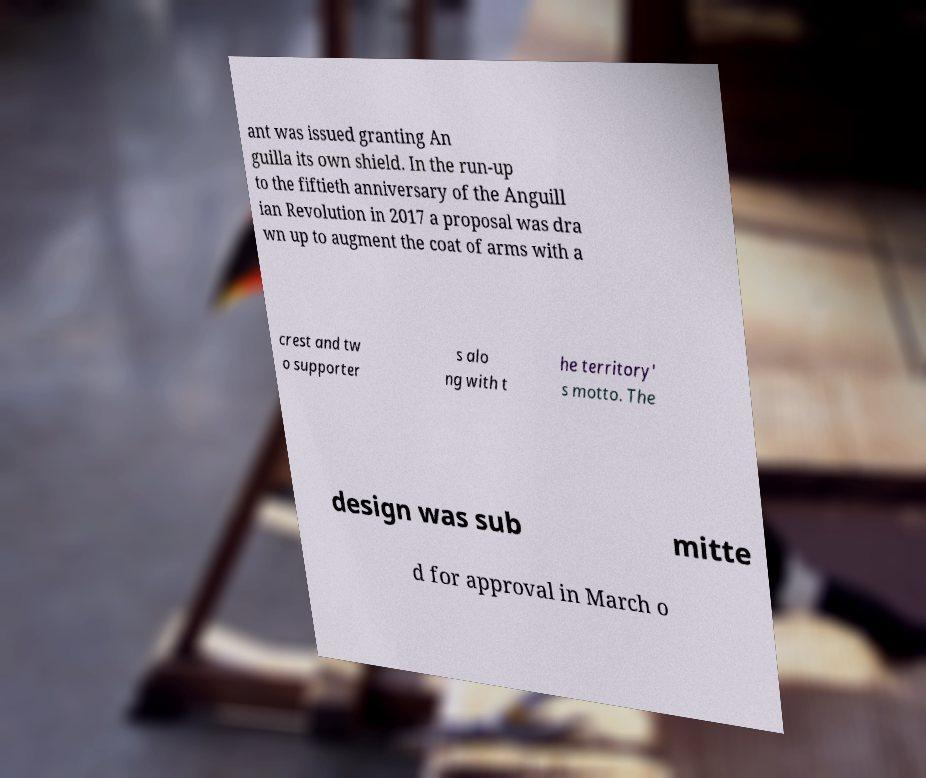I need the written content from this picture converted into text. Can you do that? ant was issued granting An guilla its own shield. In the run-up to the fiftieth anniversary of the Anguill ian Revolution in 2017 a proposal was dra wn up to augment the coat of arms with a crest and tw o supporter s alo ng with t he territory' s motto. The design was sub mitte d for approval in March o 